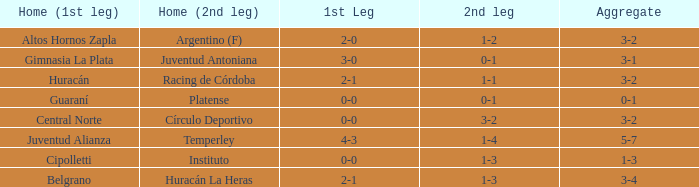Who played at home for the second leg with a score of 0-1 and tied 0-0 in the first leg? Platense. 